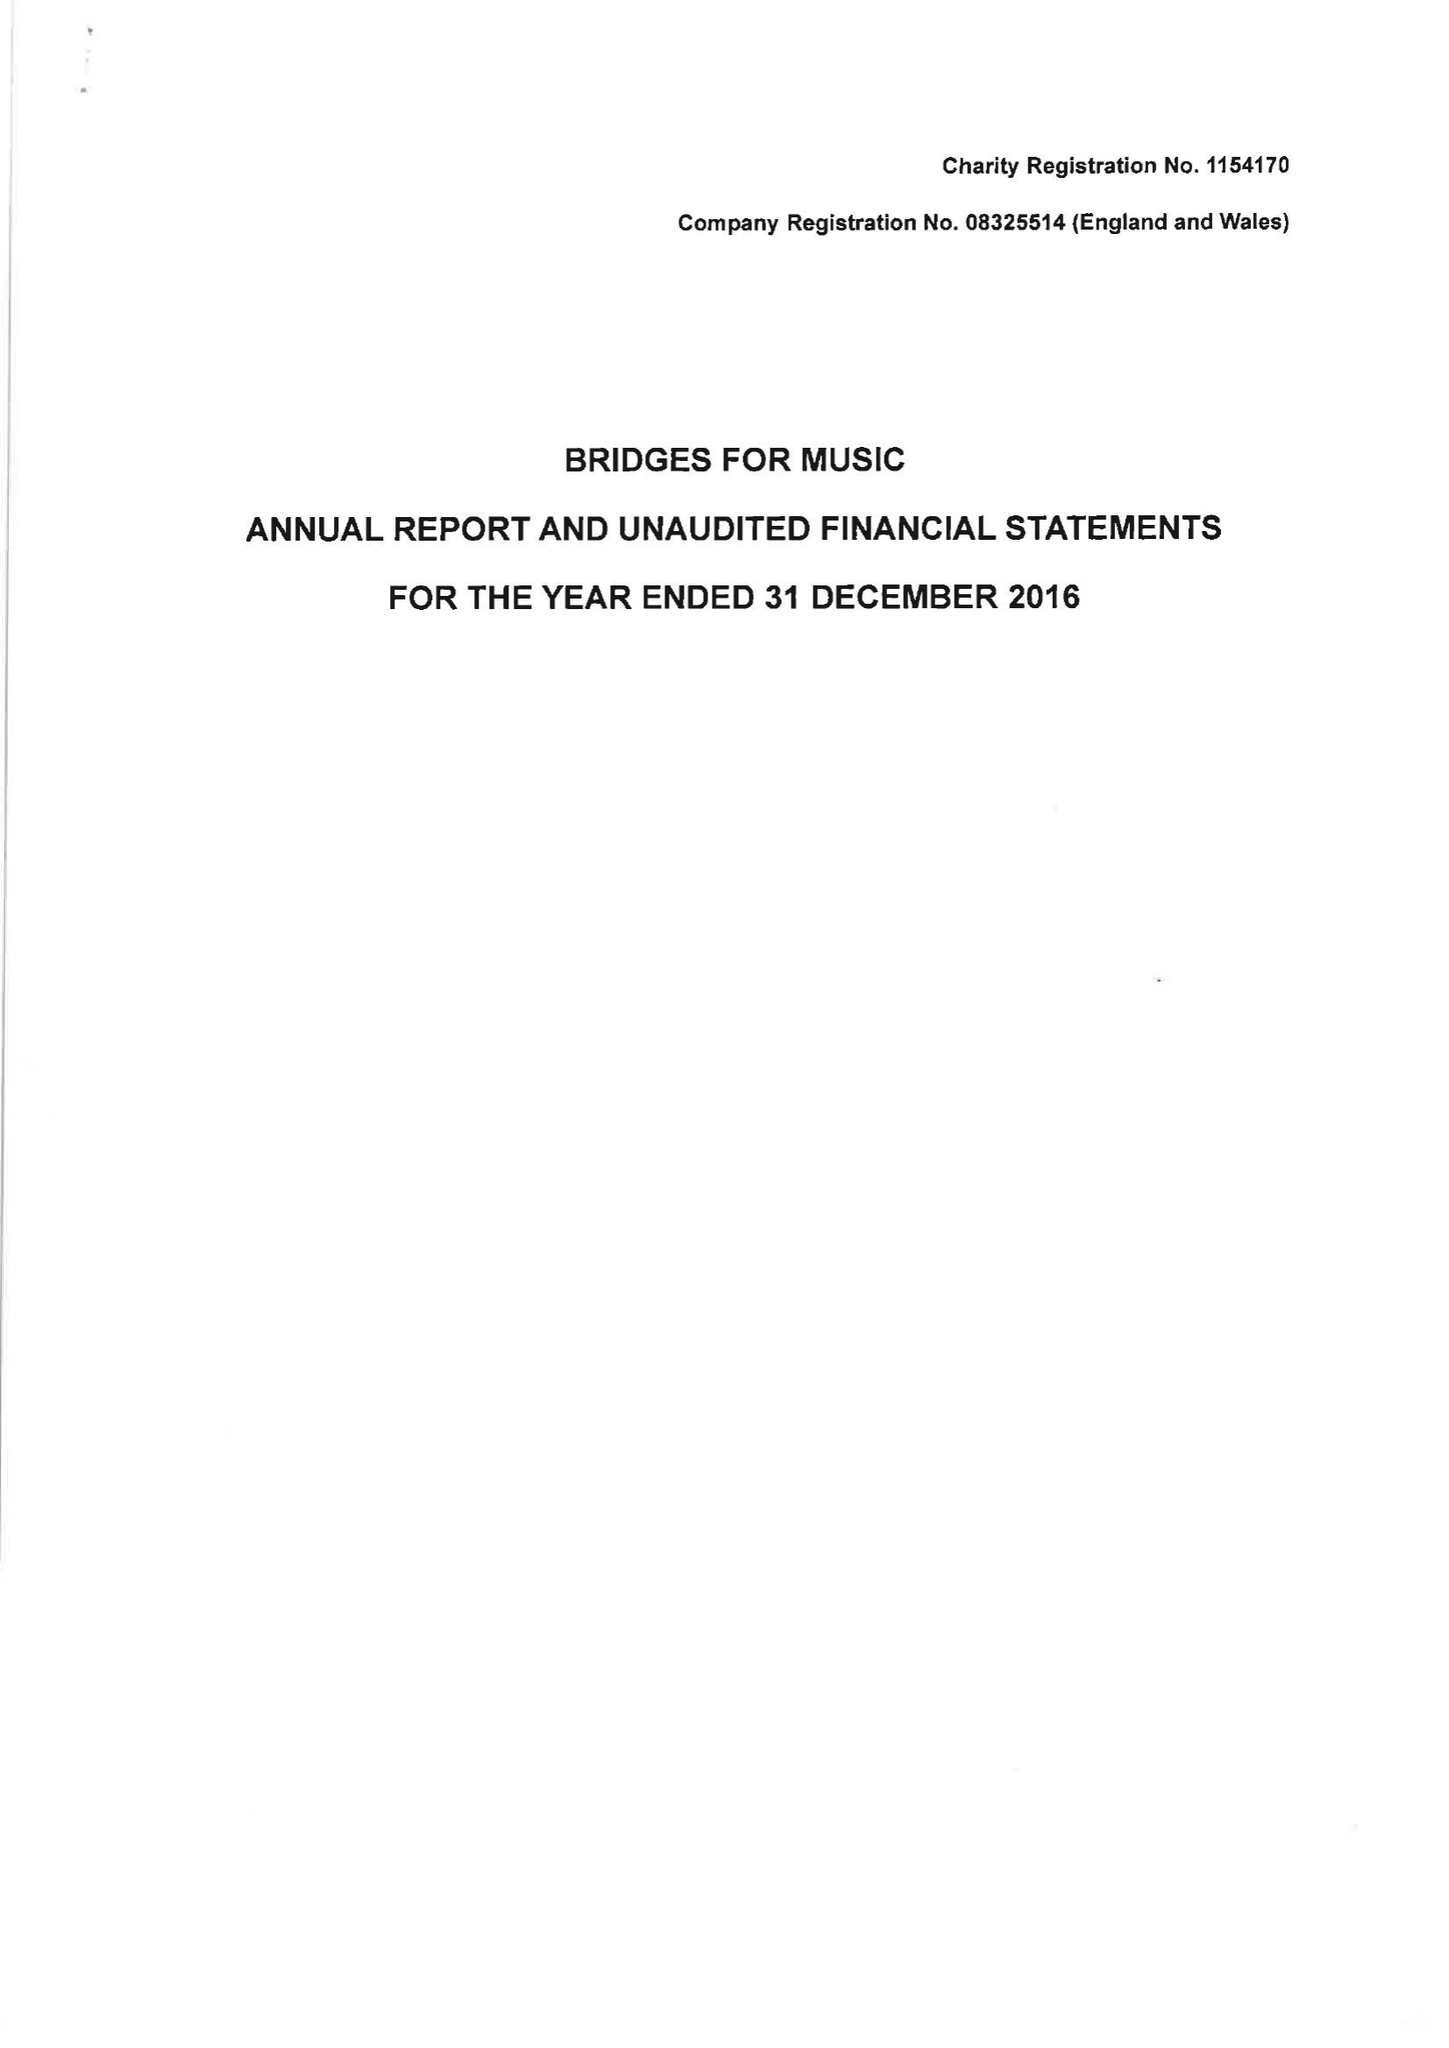What is the value for the income_annually_in_british_pounds?
Answer the question using a single word or phrase. 125053.00 